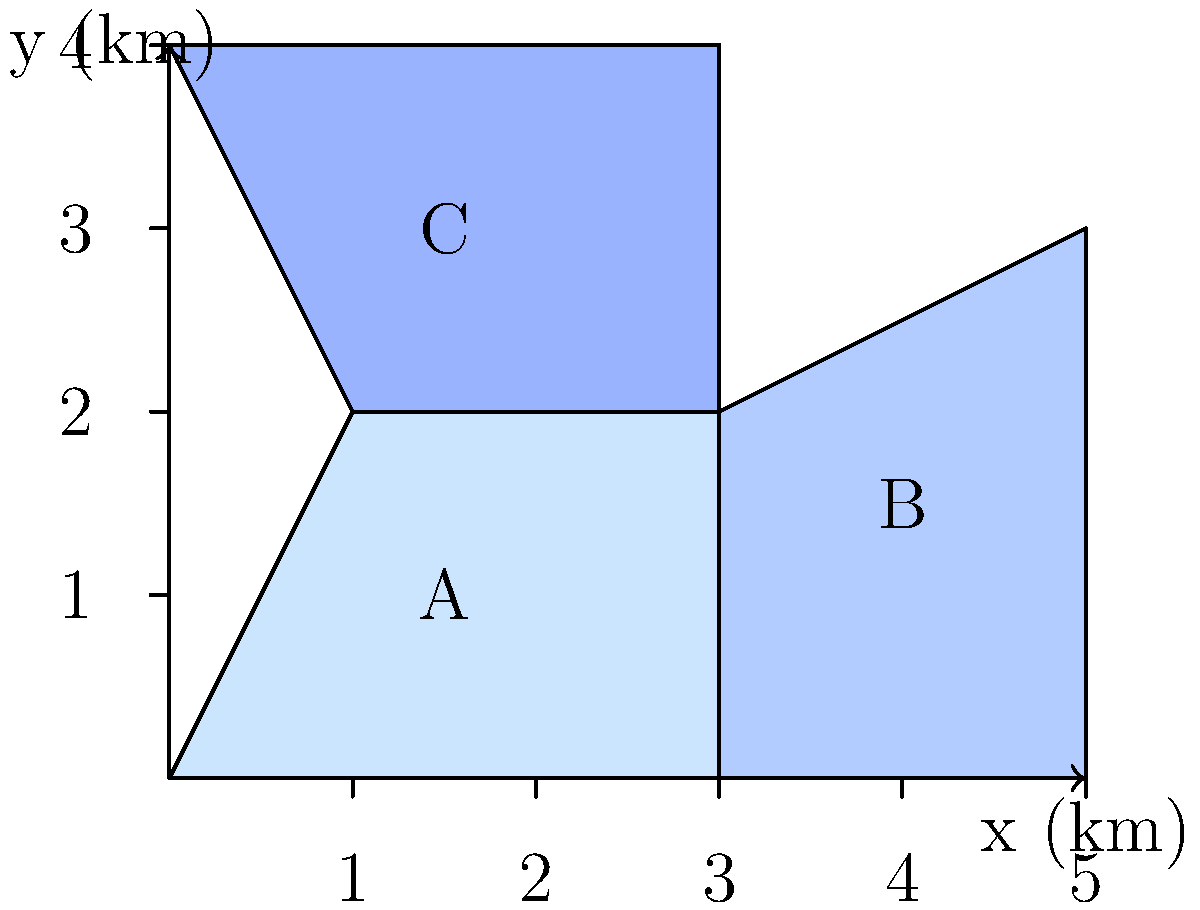As the regional manager overseeing volunteer programs, you need to calculate the total area covered by your initiatives. The map above shows three regions (A, B, and C) where volunteer programs are active. Each unit on the map represents 1 km. Calculate the total area covered by all three regions in square kilometers. To calculate the total area, we need to find the area of each region and sum them up:

1. Region A:
   Shape: Rectangle
   Area = length × width
   $A_A = 3 \text{ km} \times 2 \text{ km} = 6 \text{ km}^2$

2. Region B:
   Shape: Trapezoid
   Area = $\frac{1}{2}(b_1 + b_2)h$
   $A_B = \frac{1}{2}(2 \text{ km} + 3 \text{ km}) \times 2 \text{ km} = 5 \text{ km}^2$

3. Region C:
   Shape: Rectangle
   Area = length × width
   $A_C = 3 \text{ km} \times 2 \text{ km} = 6 \text{ km}^2$

Total area:
$A_{\text{total}} = A_A + A_B + A_C = 6 \text{ km}^2 + 5 \text{ km}^2 + 6 \text{ km}^2 = 17 \text{ km}^2$
Answer: $17 \text{ km}^2$ 